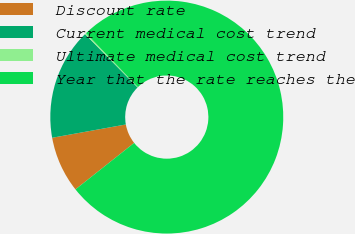Convert chart to OTSL. <chart><loc_0><loc_0><loc_500><loc_500><pie_chart><fcel>Discount rate<fcel>Current medical cost trend<fcel>Ultimate medical cost trend<fcel>Year that the rate reaches the<nl><fcel>7.82%<fcel>15.46%<fcel>0.19%<fcel>76.53%<nl></chart> 